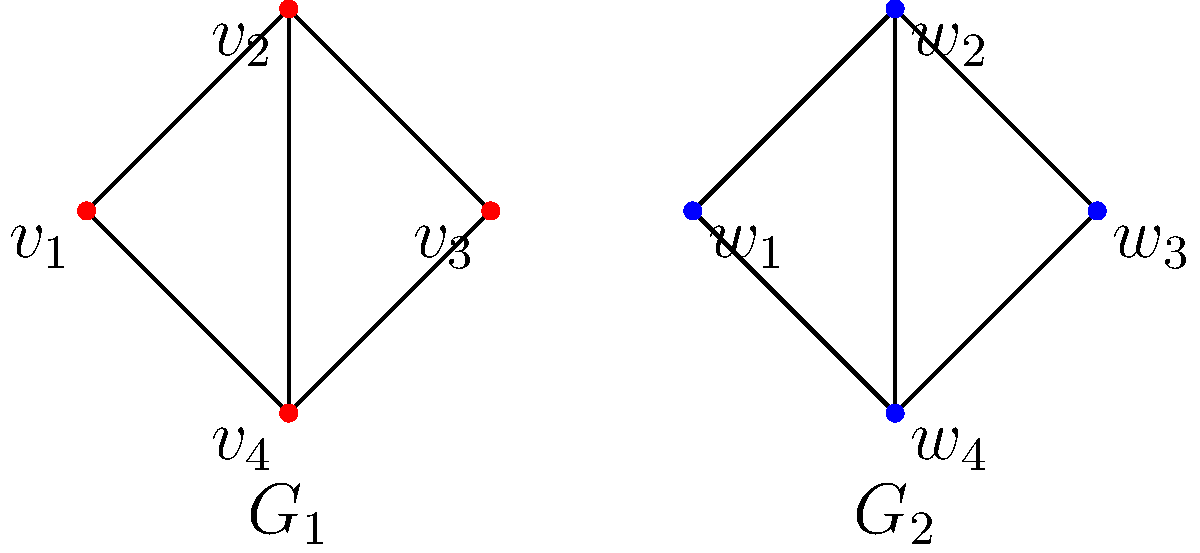Consider two neural network architectures represented as directed graphs $G_1$ and $G_2$ shown above. Are these graphs congruent? If so, provide a bijective mapping between the vertices that preserves the edge structure. If not, explain why. To determine if the graphs $G_1$ and $G_2$ are congruent, we need to check if there exists a bijective mapping between their vertices that preserves the edge structure. Let's approach this step-by-step:

1. Both graphs have 4 vertices, so a bijective mapping is possible.

2. Both graphs have the same number of edges (5 each), which is a necessary but not sufficient condition for congruence.

3. Let's analyze the degree of each vertex:
   - In $G_1$: $v_1$ (degree 2), $v_2$ (degree 3), $v_3$ (degree 2), $v_4$ (degree 3)
   - In $G_2$: $w_1$ (degree 2), $w_2$ (degree 3), $w_3$ (degree 2), $w_4$ (degree 3)

4. The degree sequences match, which is another necessary but not sufficient condition for congruence.

5. Now, let's try to construct a bijective mapping that preserves the edge structure:
   - $v_1 \leftrightarrow w_1$ (both degree 2)
   - $v_2 \leftrightarrow w_2$ (both degree 3)
   - $v_3 \leftrightarrow w_3$ (both degree 2)
   - $v_4 \leftrightarrow w_4$ (both degree 3)

6. Checking if this mapping preserves the edge structure:
   - $v_1$ is connected to $v_2$ and $v_4$; $w_1$ is connected to $w_2$ and $w_4$
   - $v_2$ is connected to $v_1$, $v_3$, and $v_4$; $w_2$ is connected to $w_1$, $w_3$, and $w_4$
   - $v_3$ is connected to $v_2$ and $v_4$; $w_3$ is connected to $w_2$ and $w_4$
   - $v_4$ is connected to $v_1$, $v_2$, and $v_3$; $w_4$ is connected to $w_1$, $w_2$, and $w_3$

7. The edge structure is preserved under this mapping.

Therefore, the graphs $G_1$ and $G_2$ are congruent, with the bijective mapping $v_i \leftrightarrow w_i$ for $i = 1, 2, 3, 4$.
Answer: Yes, congruent. Mapping: $v_i \leftrightarrow w_i$ for $i = 1, 2, 3, 4$. 